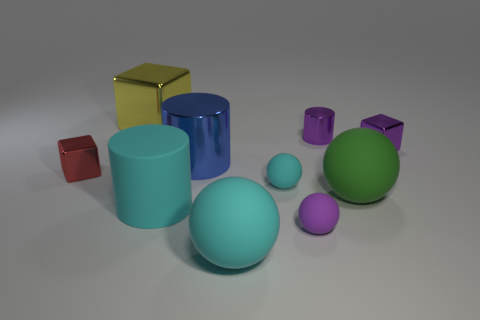What is the size of the rubber ball that is the same color as the small shiny cylinder?
Provide a short and direct response. Small. How many other objects are there of the same size as the yellow metal object?
Ensure brevity in your answer.  4. There is a cylinder behind the tiny purple metallic cube; what is it made of?
Offer a terse response. Metal. What shape is the big cyan object in front of the tiny rubber ball in front of the large sphere behind the matte cylinder?
Your answer should be very brief. Sphere. Is the green matte ball the same size as the purple metal block?
Provide a succinct answer. No. What number of things are either cyan rubber cylinders or small shiny cubes that are on the left side of the large cyan matte ball?
Your response must be concise. 2. How many objects are either things to the right of the tiny red object or objects that are left of the big block?
Offer a terse response. 10. Are there any tiny metal things behind the yellow cube?
Offer a terse response. No. The small metallic cube to the left of the tiny thing behind the metallic cube on the right side of the big green rubber ball is what color?
Make the answer very short. Red. Is the big green object the same shape as the purple rubber thing?
Offer a terse response. Yes. 